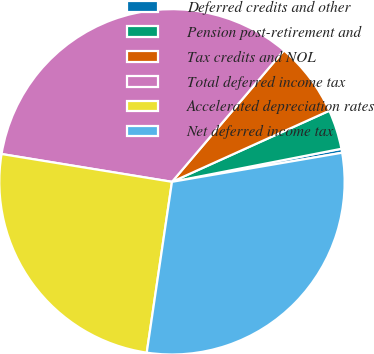<chart> <loc_0><loc_0><loc_500><loc_500><pie_chart><fcel>Deferred credits and other<fcel>Pension post-retirement and<fcel>Tax credits and NOL<fcel>Total deferred income tax<fcel>Accelerated depreciation rates<fcel>Net deferred income tax<nl><fcel>0.37%<fcel>3.69%<fcel>7.02%<fcel>33.65%<fcel>25.24%<fcel>30.03%<nl></chart> 